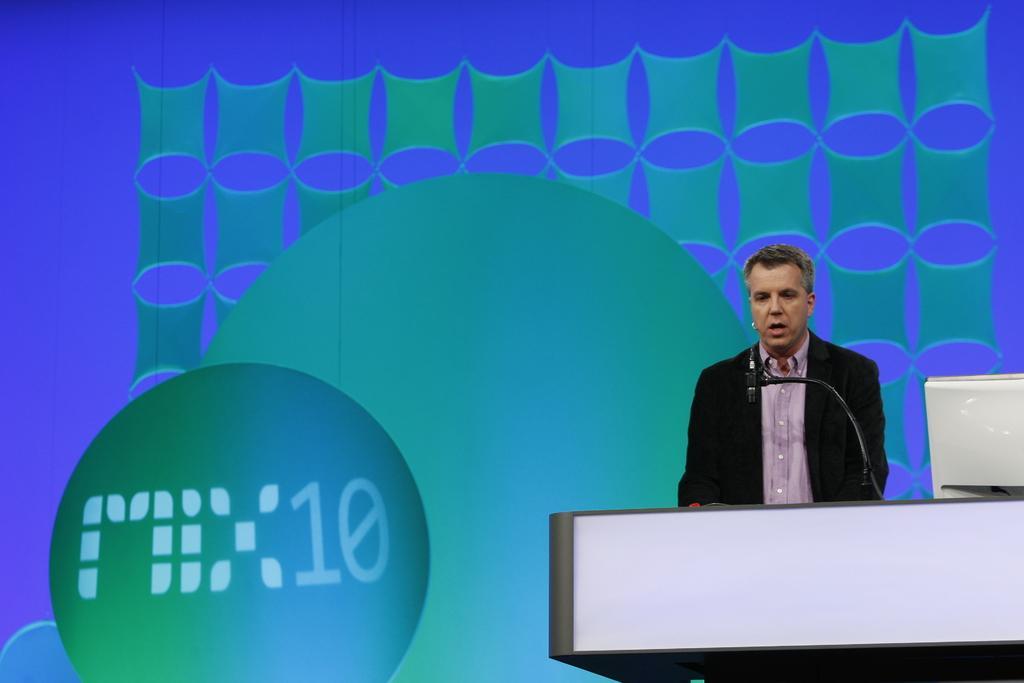Describe this image in one or two sentences. In this picture we can see a man is speaking something, we can see a table and a microphone in front of him, on the right side there is a monitor, it looks like a screen in the background. 